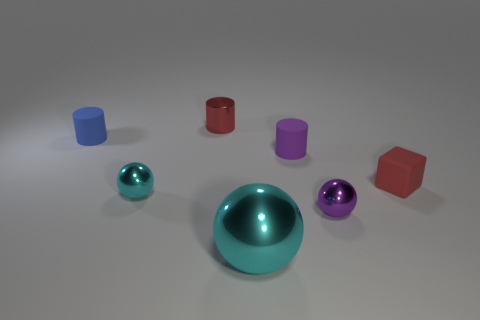How many purple rubber cylinders have the same size as the red metal object? 1 